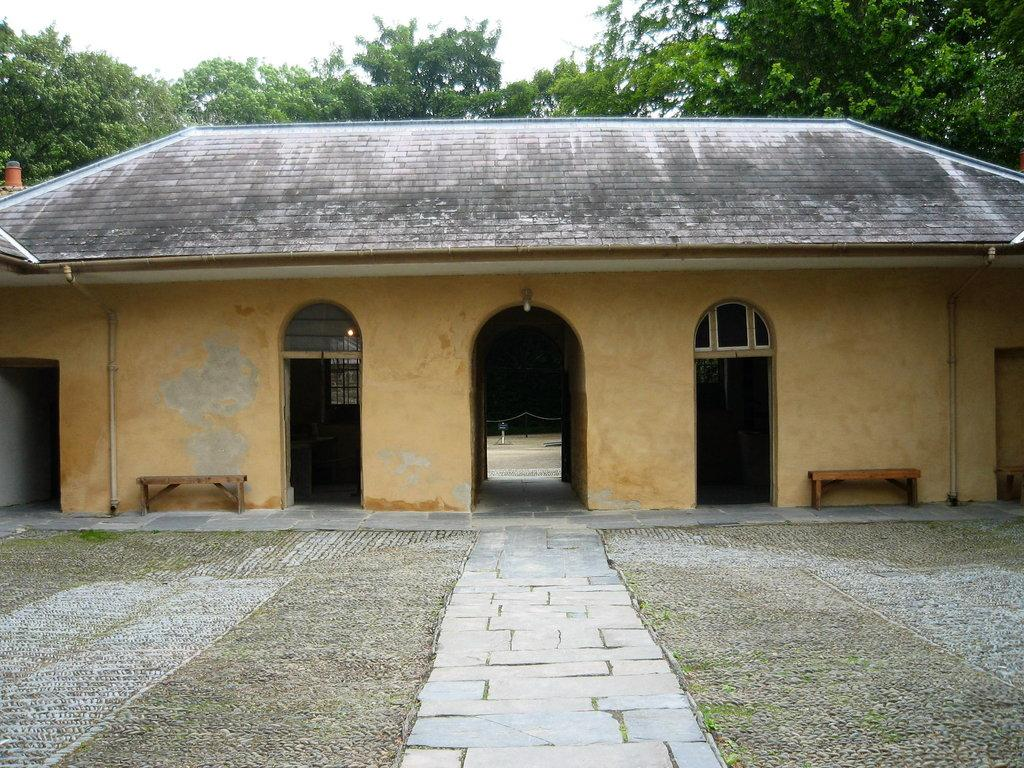What type of structure is present in the image? There is a house in the image. What can be found near the house? There are benches and a path in the image. What is visible in the background of the image? There are trees and the sky in the background of the image. What is the name of the person wearing a shirt in the image? There is no person wearing a shirt in the image; the focus is on the house, benches, path, trees, and sky. 